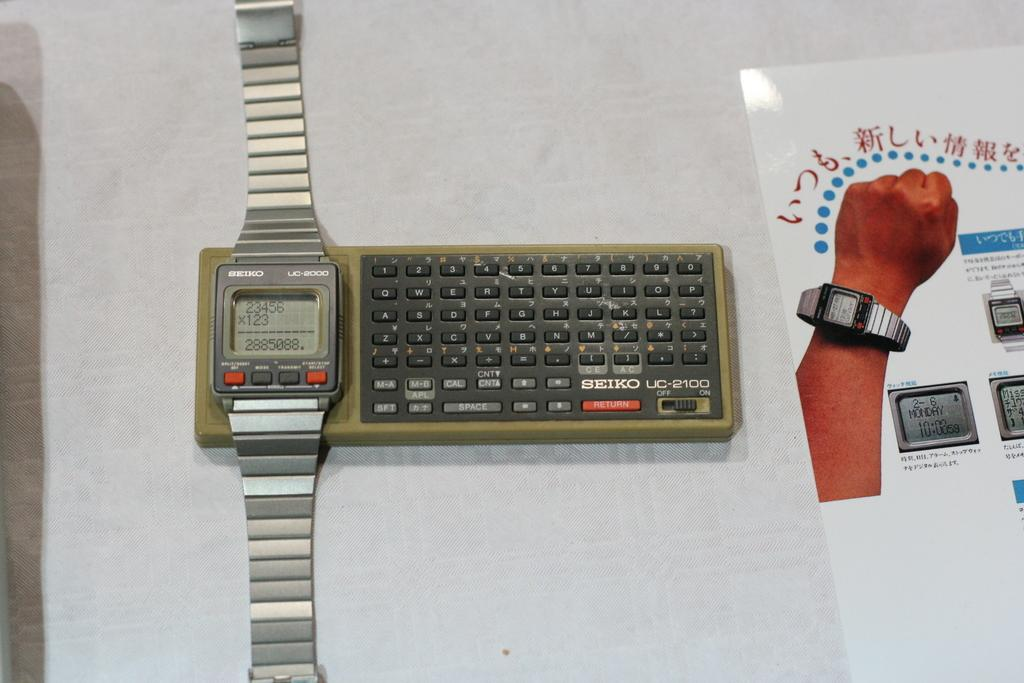<image>
Write a terse but informative summary of the picture. A Seiko wristwatch and other device lying together on a table. 